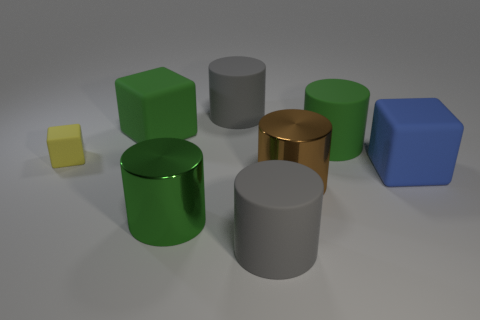Subtract all green matte cylinders. How many cylinders are left? 4 Subtract all brown balls. How many green cylinders are left? 2 Subtract all brown cylinders. How many cylinders are left? 4 Subtract all cyan blocks. Subtract all blue balls. How many blocks are left? 3 Add 1 small red rubber spheres. How many objects exist? 9 Subtract all cylinders. How many objects are left? 3 Add 7 yellow rubber things. How many yellow rubber things exist? 8 Subtract 0 blue spheres. How many objects are left? 8 Subtract all red cylinders. Subtract all large things. How many objects are left? 1 Add 7 large green rubber cylinders. How many large green rubber cylinders are left? 8 